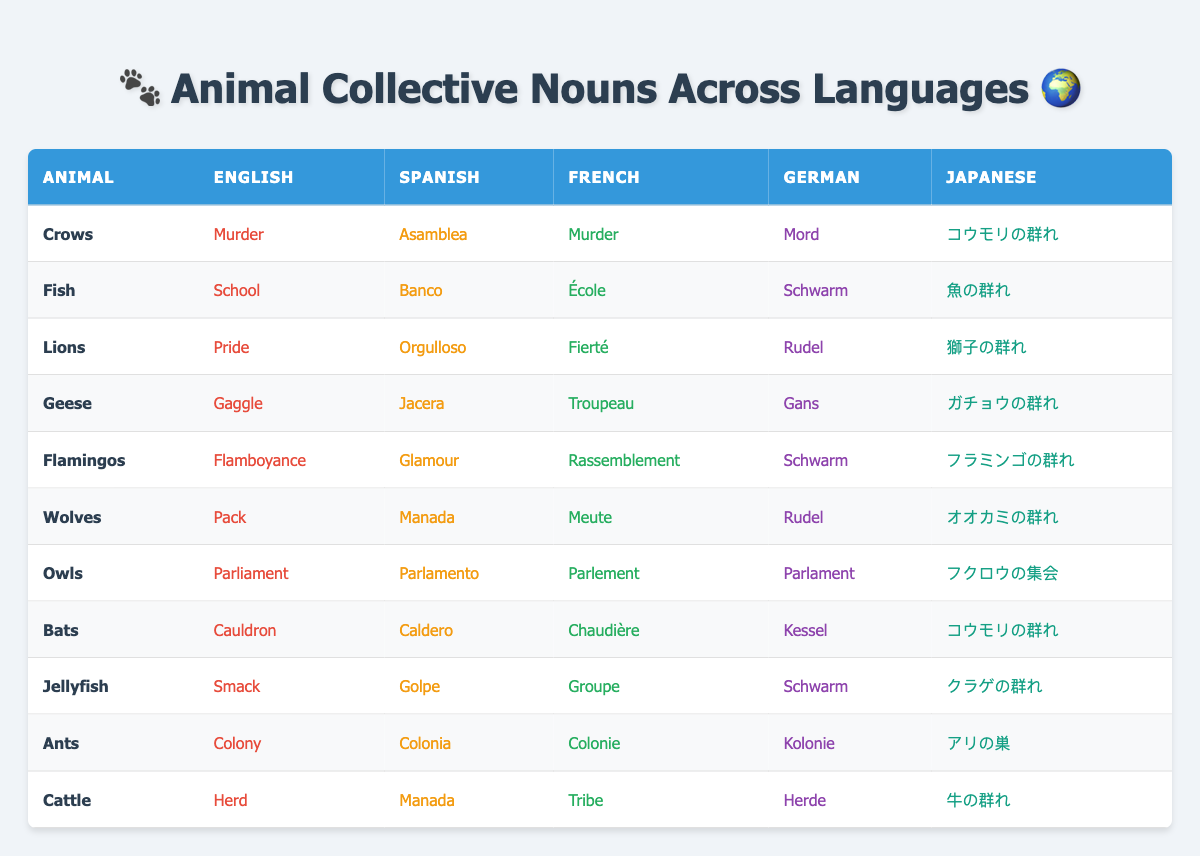What is the collective noun for crows in Spanish? In the table under the 'Spanish' column for 'Crows', the collective noun is listed as 'Asamblea'.
Answer: Asamblea What is the French collective noun for lions? Referring to the 'French' column under 'Lions', the collective noun is 'Fierté'.
Answer: Fierté How many animals on the list have the same collective noun in English and French? By examining the table, 'Crows' and 'Lions' both have 'Murder' and 'Pride' in English and French respectively, so the answer is 2.
Answer: 2 What is the German collective noun for jellyfish? Looking at the 'German' column for 'Jellyfish', the collective noun is 'Schwarm'.
Answer: Schwarm Is the collective noun for cattle the same in Spanish and German? Under the 'Spanish' column for 'Cattle', the noun is 'Manada', and in the 'German' column it is 'Herde'. They are different, so the answer is No.
Answer: No Which animal shares a collective noun with both English and French? Checking the table, 'Crows' has 'Murder' in both English and French. Therefore, the answer is 'Crows'.
Answer: Crows How many different collective nouns are listed for wolves in any language? The table shows that the collective noun for 'Wolves' is 'Pack' in English, 'Manada' in Spanish, 'Meute' in French, 'Rudel' in German, and 'オオカミの群れ' in Japanese, resulting in a total of 5 distinct nouns.
Answer: 5 Which animal has the unique collective noun 'Flamboyance' and in which language is it used? The table indicates that only 'Flamingos' has 'Flamboyance' as the collective noun, used in English.
Answer: Flamingos, English How does the collective noun for owls differ between English and German? The 'English' column for 'Owls' shows 'Parliament,' while the 'German' column shows 'Parlament'. Thus, they differ in spelling but convey the same concept.
Answer: They differ in spelling Which language uses 'Caldero' for bats and what does it translate to in English? According to the table, 'Caldero' for 'Bats' is in Spanish, which translates to 'Cauldron' in English.
Answer: Cauldron, Spanish 